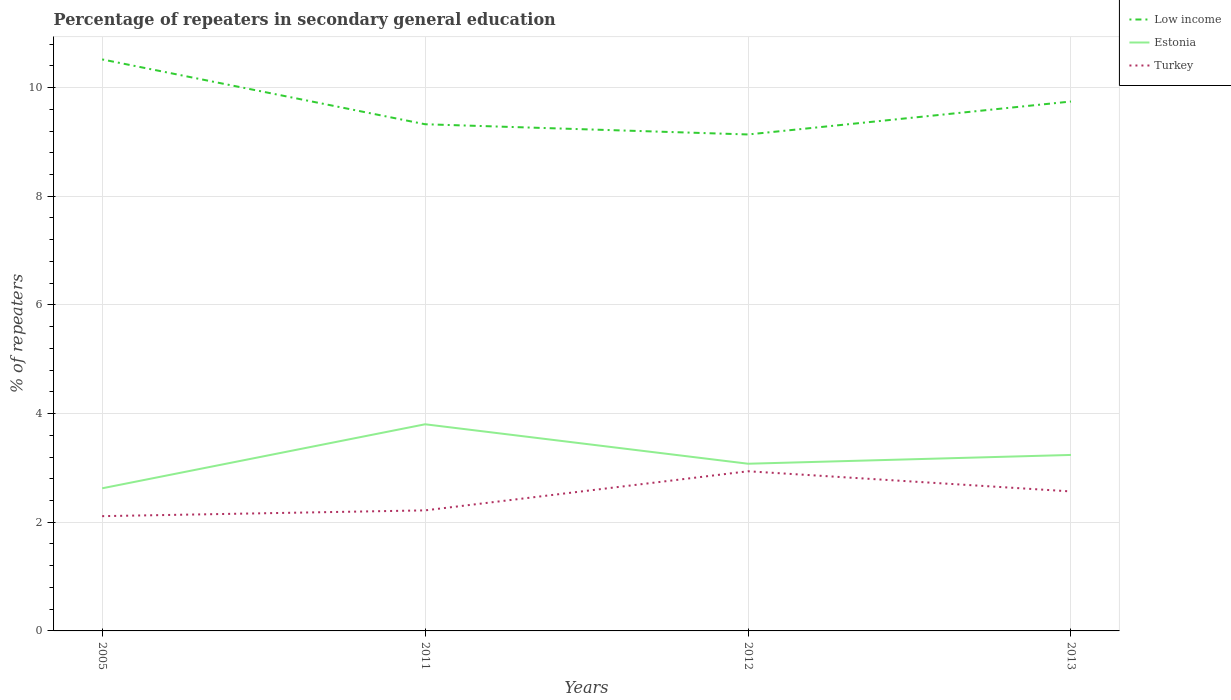Does the line corresponding to Estonia intersect with the line corresponding to Low income?
Provide a short and direct response. No. Is the number of lines equal to the number of legend labels?
Offer a terse response. Yes. Across all years, what is the maximum percentage of repeaters in secondary general education in Low income?
Give a very brief answer. 9.14. What is the total percentage of repeaters in secondary general education in Estonia in the graph?
Keep it short and to the point. 0.73. What is the difference between the highest and the second highest percentage of repeaters in secondary general education in Estonia?
Give a very brief answer. 1.18. How many lines are there?
Your response must be concise. 3. What is the difference between two consecutive major ticks on the Y-axis?
Provide a succinct answer. 2. Are the values on the major ticks of Y-axis written in scientific E-notation?
Ensure brevity in your answer.  No. Does the graph contain any zero values?
Provide a succinct answer. No. How many legend labels are there?
Keep it short and to the point. 3. How are the legend labels stacked?
Your answer should be compact. Vertical. What is the title of the graph?
Keep it short and to the point. Percentage of repeaters in secondary general education. Does "Pakistan" appear as one of the legend labels in the graph?
Provide a succinct answer. No. What is the label or title of the X-axis?
Offer a terse response. Years. What is the label or title of the Y-axis?
Make the answer very short. % of repeaters. What is the % of repeaters in Low income in 2005?
Keep it short and to the point. 10.52. What is the % of repeaters in Estonia in 2005?
Your answer should be very brief. 2.62. What is the % of repeaters in Turkey in 2005?
Your answer should be very brief. 2.11. What is the % of repeaters in Low income in 2011?
Your answer should be very brief. 9.33. What is the % of repeaters in Estonia in 2011?
Give a very brief answer. 3.8. What is the % of repeaters in Turkey in 2011?
Give a very brief answer. 2.22. What is the % of repeaters in Low income in 2012?
Make the answer very short. 9.14. What is the % of repeaters of Estonia in 2012?
Make the answer very short. 3.08. What is the % of repeaters of Turkey in 2012?
Your answer should be compact. 2.94. What is the % of repeaters of Low income in 2013?
Offer a very short reply. 9.74. What is the % of repeaters of Estonia in 2013?
Your answer should be very brief. 3.24. What is the % of repeaters in Turkey in 2013?
Offer a terse response. 2.57. Across all years, what is the maximum % of repeaters of Low income?
Ensure brevity in your answer.  10.52. Across all years, what is the maximum % of repeaters of Estonia?
Provide a short and direct response. 3.8. Across all years, what is the maximum % of repeaters of Turkey?
Make the answer very short. 2.94. Across all years, what is the minimum % of repeaters of Low income?
Provide a succinct answer. 9.14. Across all years, what is the minimum % of repeaters in Estonia?
Offer a very short reply. 2.62. Across all years, what is the minimum % of repeaters of Turkey?
Give a very brief answer. 2.11. What is the total % of repeaters in Low income in the graph?
Your answer should be compact. 38.73. What is the total % of repeaters in Estonia in the graph?
Offer a terse response. 12.74. What is the total % of repeaters of Turkey in the graph?
Ensure brevity in your answer.  9.84. What is the difference between the % of repeaters of Low income in 2005 and that in 2011?
Keep it short and to the point. 1.19. What is the difference between the % of repeaters of Estonia in 2005 and that in 2011?
Offer a terse response. -1.18. What is the difference between the % of repeaters in Turkey in 2005 and that in 2011?
Your answer should be very brief. -0.11. What is the difference between the % of repeaters of Low income in 2005 and that in 2012?
Offer a very short reply. 1.38. What is the difference between the % of repeaters in Estonia in 2005 and that in 2012?
Your answer should be very brief. -0.45. What is the difference between the % of repeaters of Turkey in 2005 and that in 2012?
Your answer should be compact. -0.83. What is the difference between the % of repeaters of Low income in 2005 and that in 2013?
Provide a short and direct response. 0.77. What is the difference between the % of repeaters of Estonia in 2005 and that in 2013?
Ensure brevity in your answer.  -0.61. What is the difference between the % of repeaters in Turkey in 2005 and that in 2013?
Give a very brief answer. -0.46. What is the difference between the % of repeaters in Low income in 2011 and that in 2012?
Keep it short and to the point. 0.19. What is the difference between the % of repeaters of Estonia in 2011 and that in 2012?
Your response must be concise. 0.73. What is the difference between the % of repeaters of Turkey in 2011 and that in 2012?
Make the answer very short. -0.72. What is the difference between the % of repeaters of Low income in 2011 and that in 2013?
Your response must be concise. -0.42. What is the difference between the % of repeaters of Estonia in 2011 and that in 2013?
Your answer should be compact. 0.56. What is the difference between the % of repeaters of Turkey in 2011 and that in 2013?
Give a very brief answer. -0.35. What is the difference between the % of repeaters of Low income in 2012 and that in 2013?
Keep it short and to the point. -0.61. What is the difference between the % of repeaters of Estonia in 2012 and that in 2013?
Offer a very short reply. -0.16. What is the difference between the % of repeaters in Turkey in 2012 and that in 2013?
Your answer should be compact. 0.37. What is the difference between the % of repeaters in Low income in 2005 and the % of repeaters in Estonia in 2011?
Keep it short and to the point. 6.72. What is the difference between the % of repeaters of Low income in 2005 and the % of repeaters of Turkey in 2011?
Give a very brief answer. 8.3. What is the difference between the % of repeaters in Estonia in 2005 and the % of repeaters in Turkey in 2011?
Your answer should be very brief. 0.41. What is the difference between the % of repeaters in Low income in 2005 and the % of repeaters in Estonia in 2012?
Ensure brevity in your answer.  7.44. What is the difference between the % of repeaters in Low income in 2005 and the % of repeaters in Turkey in 2012?
Give a very brief answer. 7.58. What is the difference between the % of repeaters of Estonia in 2005 and the % of repeaters of Turkey in 2012?
Make the answer very short. -0.31. What is the difference between the % of repeaters of Low income in 2005 and the % of repeaters of Estonia in 2013?
Your answer should be very brief. 7.28. What is the difference between the % of repeaters in Low income in 2005 and the % of repeaters in Turkey in 2013?
Ensure brevity in your answer.  7.95. What is the difference between the % of repeaters of Estonia in 2005 and the % of repeaters of Turkey in 2013?
Provide a succinct answer. 0.06. What is the difference between the % of repeaters of Low income in 2011 and the % of repeaters of Estonia in 2012?
Ensure brevity in your answer.  6.25. What is the difference between the % of repeaters in Low income in 2011 and the % of repeaters in Turkey in 2012?
Provide a succinct answer. 6.39. What is the difference between the % of repeaters in Estonia in 2011 and the % of repeaters in Turkey in 2012?
Your response must be concise. 0.86. What is the difference between the % of repeaters in Low income in 2011 and the % of repeaters in Estonia in 2013?
Your answer should be very brief. 6.09. What is the difference between the % of repeaters of Low income in 2011 and the % of repeaters of Turkey in 2013?
Make the answer very short. 6.76. What is the difference between the % of repeaters of Estonia in 2011 and the % of repeaters of Turkey in 2013?
Keep it short and to the point. 1.24. What is the difference between the % of repeaters of Low income in 2012 and the % of repeaters of Estonia in 2013?
Your response must be concise. 5.9. What is the difference between the % of repeaters of Low income in 2012 and the % of repeaters of Turkey in 2013?
Your response must be concise. 6.57. What is the difference between the % of repeaters of Estonia in 2012 and the % of repeaters of Turkey in 2013?
Provide a succinct answer. 0.51. What is the average % of repeaters in Low income per year?
Ensure brevity in your answer.  9.68. What is the average % of repeaters of Estonia per year?
Ensure brevity in your answer.  3.19. What is the average % of repeaters of Turkey per year?
Give a very brief answer. 2.46. In the year 2005, what is the difference between the % of repeaters in Low income and % of repeaters in Estonia?
Provide a succinct answer. 7.89. In the year 2005, what is the difference between the % of repeaters in Low income and % of repeaters in Turkey?
Your response must be concise. 8.41. In the year 2005, what is the difference between the % of repeaters of Estonia and % of repeaters of Turkey?
Offer a very short reply. 0.51. In the year 2011, what is the difference between the % of repeaters in Low income and % of repeaters in Estonia?
Your answer should be compact. 5.52. In the year 2011, what is the difference between the % of repeaters of Low income and % of repeaters of Turkey?
Ensure brevity in your answer.  7.11. In the year 2011, what is the difference between the % of repeaters in Estonia and % of repeaters in Turkey?
Make the answer very short. 1.58. In the year 2012, what is the difference between the % of repeaters of Low income and % of repeaters of Estonia?
Your response must be concise. 6.06. In the year 2012, what is the difference between the % of repeaters in Low income and % of repeaters in Turkey?
Offer a very short reply. 6.2. In the year 2012, what is the difference between the % of repeaters of Estonia and % of repeaters of Turkey?
Keep it short and to the point. 0.14. In the year 2013, what is the difference between the % of repeaters of Low income and % of repeaters of Estonia?
Your answer should be compact. 6.51. In the year 2013, what is the difference between the % of repeaters of Low income and % of repeaters of Turkey?
Ensure brevity in your answer.  7.18. In the year 2013, what is the difference between the % of repeaters of Estonia and % of repeaters of Turkey?
Keep it short and to the point. 0.67. What is the ratio of the % of repeaters in Low income in 2005 to that in 2011?
Ensure brevity in your answer.  1.13. What is the ratio of the % of repeaters of Estonia in 2005 to that in 2011?
Give a very brief answer. 0.69. What is the ratio of the % of repeaters in Low income in 2005 to that in 2012?
Give a very brief answer. 1.15. What is the ratio of the % of repeaters of Estonia in 2005 to that in 2012?
Offer a very short reply. 0.85. What is the ratio of the % of repeaters in Turkey in 2005 to that in 2012?
Your answer should be very brief. 0.72. What is the ratio of the % of repeaters of Low income in 2005 to that in 2013?
Ensure brevity in your answer.  1.08. What is the ratio of the % of repeaters of Estonia in 2005 to that in 2013?
Provide a short and direct response. 0.81. What is the ratio of the % of repeaters in Turkey in 2005 to that in 2013?
Give a very brief answer. 0.82. What is the ratio of the % of repeaters of Low income in 2011 to that in 2012?
Ensure brevity in your answer.  1.02. What is the ratio of the % of repeaters in Estonia in 2011 to that in 2012?
Provide a succinct answer. 1.24. What is the ratio of the % of repeaters in Turkey in 2011 to that in 2012?
Give a very brief answer. 0.76. What is the ratio of the % of repeaters of Low income in 2011 to that in 2013?
Your answer should be very brief. 0.96. What is the ratio of the % of repeaters of Estonia in 2011 to that in 2013?
Offer a very short reply. 1.17. What is the ratio of the % of repeaters in Turkey in 2011 to that in 2013?
Give a very brief answer. 0.86. What is the ratio of the % of repeaters in Low income in 2012 to that in 2013?
Provide a short and direct response. 0.94. What is the ratio of the % of repeaters in Estonia in 2012 to that in 2013?
Provide a succinct answer. 0.95. What is the ratio of the % of repeaters in Turkey in 2012 to that in 2013?
Provide a short and direct response. 1.14. What is the difference between the highest and the second highest % of repeaters of Low income?
Offer a terse response. 0.77. What is the difference between the highest and the second highest % of repeaters of Estonia?
Your answer should be compact. 0.56. What is the difference between the highest and the second highest % of repeaters of Turkey?
Your answer should be compact. 0.37. What is the difference between the highest and the lowest % of repeaters of Low income?
Your answer should be very brief. 1.38. What is the difference between the highest and the lowest % of repeaters in Estonia?
Give a very brief answer. 1.18. What is the difference between the highest and the lowest % of repeaters in Turkey?
Your response must be concise. 0.83. 